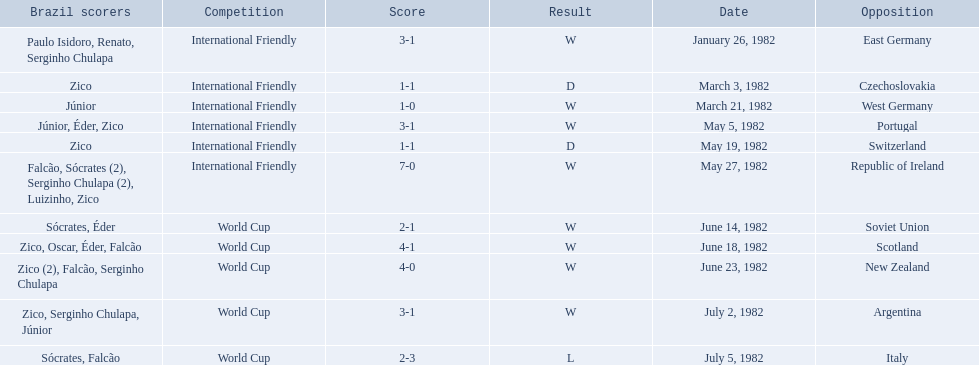Help me parse the entirety of this table. {'header': ['Brazil scorers', 'Competition', 'Score', 'Result', 'Date', 'Opposition'], 'rows': [['Paulo Isidoro, Renato, Serginho Chulapa', 'International Friendly', '3-1', 'W', 'January 26, 1982', 'East Germany'], ['Zico', 'International Friendly', '1-1', 'D', 'March 3, 1982', 'Czechoslovakia'], ['Júnior', 'International Friendly', '1-0', 'W', 'March 21, 1982', 'West Germany'], ['Júnior, Éder, Zico', 'International Friendly', '3-1', 'W', 'May 5, 1982', 'Portugal'], ['Zico', 'International Friendly', '1-1', 'D', 'May 19, 1982', 'Switzerland'], ['Falcão, Sócrates (2), Serginho Chulapa (2), Luizinho, Zico', 'International Friendly', '7-0', 'W', 'May 27, 1982', 'Republic of Ireland'], ['Sócrates, Éder', 'World Cup', '2-1', 'W', 'June 14, 1982', 'Soviet Union'], ['Zico, Oscar, Éder, Falcão', 'World Cup', '4-1', 'W', 'June 18, 1982', 'Scotland'], ['Zico (2), Falcão, Serginho Chulapa', 'World Cup', '4-0', 'W', 'June 23, 1982', 'New Zealand'], ['Zico, Serginho Chulapa, Júnior', 'World Cup', '3-1', 'W', 'July 2, 1982', 'Argentina'], ['Sócrates, Falcão', 'World Cup', '2-3', 'L', 'July 5, 1982', 'Italy']]} How many goals did brazil score against the soviet union? 2-1. How many goals did brazil score against portugal? 3-1. Did brazil score more goals against portugal or the soviet union? Portugal. 